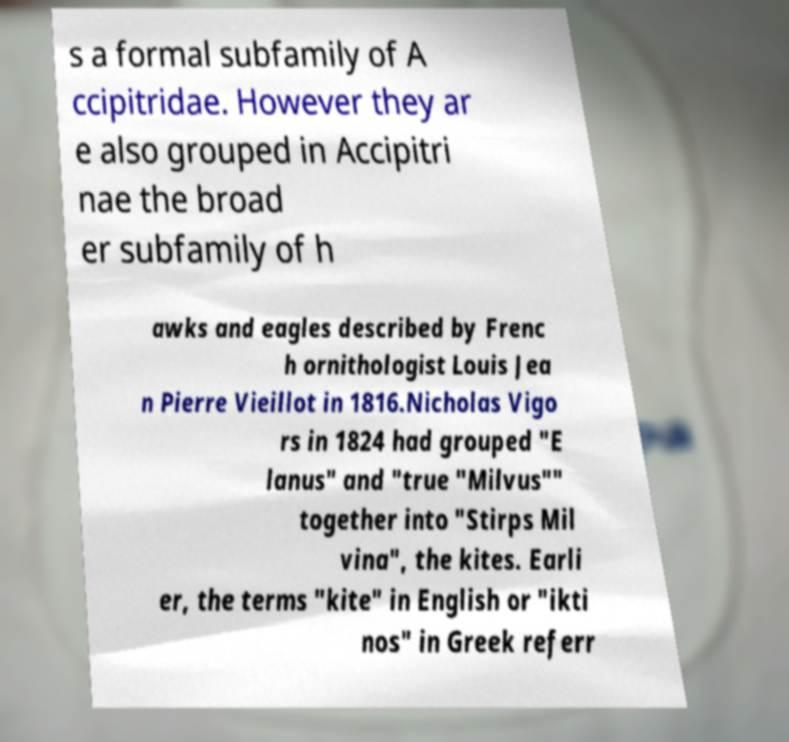There's text embedded in this image that I need extracted. Can you transcribe it verbatim? s a formal subfamily of A ccipitridae. However they ar e also grouped in Accipitri nae the broad er subfamily of h awks and eagles described by Frenc h ornithologist Louis Jea n Pierre Vieillot in 1816.Nicholas Vigo rs in 1824 had grouped "E lanus" and "true "Milvus"" together into "Stirps Mil vina", the kites. Earli er, the terms "kite" in English or "ikti nos" in Greek referr 